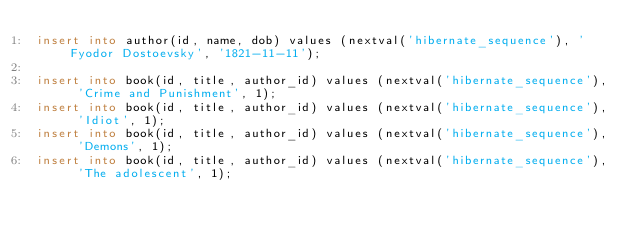<code> <loc_0><loc_0><loc_500><loc_500><_SQL_>insert into author(id, name, dob) values (nextval('hibernate_sequence'), 'Fyodor Dostoevsky', '1821-11-11');

insert into book(id, title, author_id) values (nextval('hibernate_sequence'), 'Crime and Punishment', 1);
insert into book(id, title, author_id) values (nextval('hibernate_sequence'), 'Idiot', 1);
insert into book(id, title, author_id) values (nextval('hibernate_sequence'), 'Demons', 1);
insert into book(id, title, author_id) values (nextval('hibernate_sequence'), 'The adolescent', 1);
</code> 